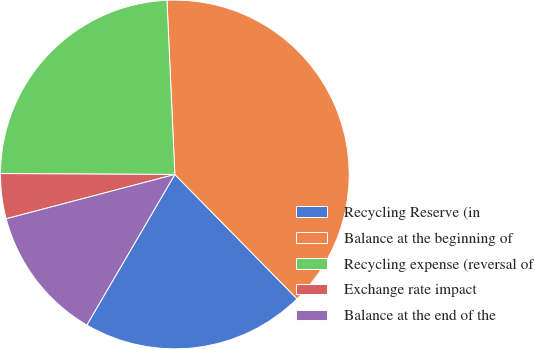<chart> <loc_0><loc_0><loc_500><loc_500><pie_chart><fcel>Recycling Reserve (in<fcel>Balance at the beginning of<fcel>Recycling expense (reversal of<fcel>Exchange rate impact<fcel>Balance at the end of the<nl><fcel>20.78%<fcel>38.36%<fcel>24.2%<fcel>4.17%<fcel>12.49%<nl></chart> 